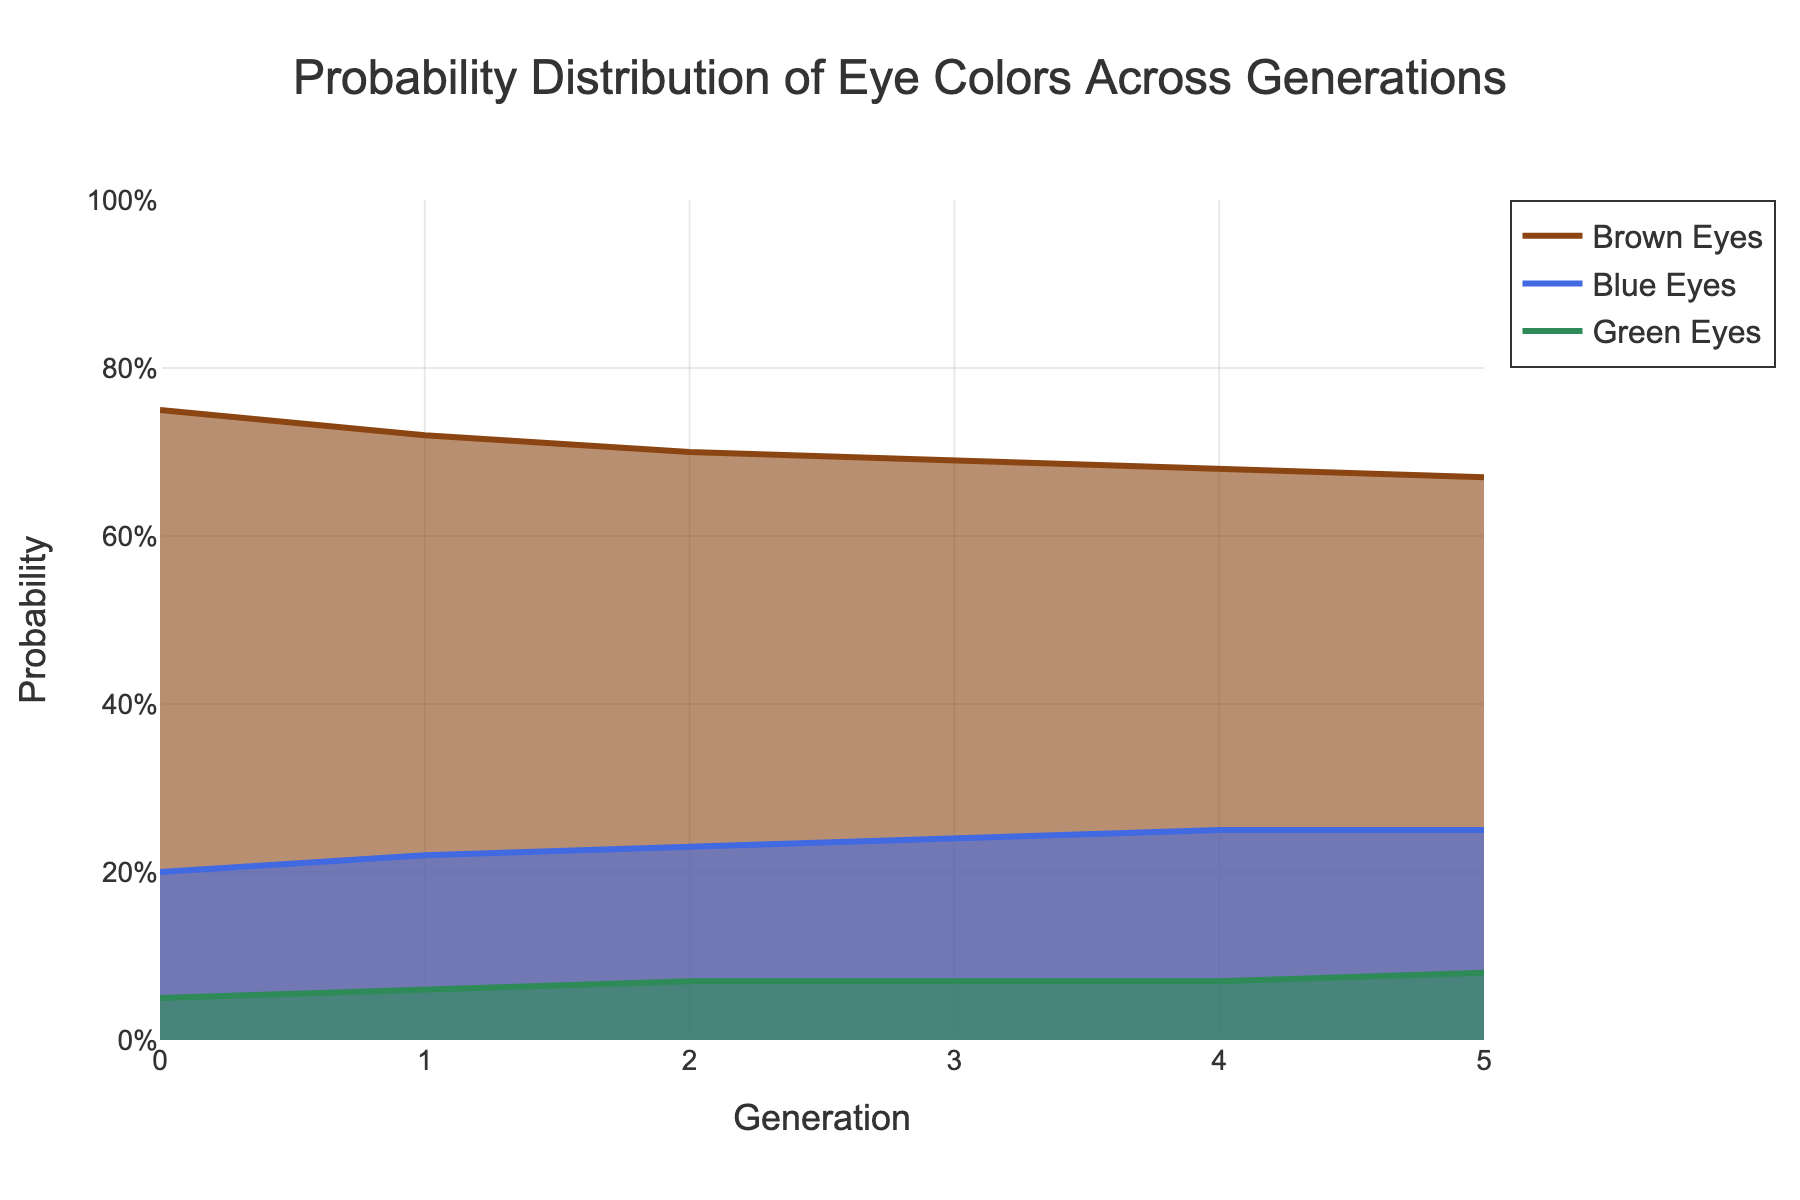What is the title of the figure? The title is displayed prominently at the top of the figure, indicating what the plot represents.
Answer: Probability Distribution of Eye Colors Across Generations What is the probability of having blue eyes in generation 2? Locate the line and area for blue eyes, and check the value on the y-axis where it intersects at generation 2 on the x-axis.
Answer: 0.23 How does the probability of having brown eyes change from generation 0 to generation 5? The probability of brown eyes starts at 0.75 in generation 0 and decreases slightly to 0.67 in generation 5.
Answer: It decreases by 0.08 Comparing the probabilities of blue eyes and green eyes in generation 4, which one is higher and by how much? Look at the y-axis values where the blue and green lines intersect with generation 4 on the x-axis. Blue eyes have a probability of 0.25 and green eyes have 0.07. The difference is 0.25 - 0.07.
Answer: Blue eyes, by 0.18 What trend do you observe for the probability of green eyes from generation 0 to generation 5? Observing the green area and line, the probability increases slightly over generations from 0.05 to 0.08.
Answer: It increases slightly What is the total probability for all the traits in generation 3? Sum up the probabilities of all traits in generation 3: 0.69 (Brown) + 0.24 (Blue) + 0.07 (Green).
Answer: 1.00 Which eye color has the most consistent probability over the generations? Compare the lines for each eye color. The line for Green eyes appears to be the most horizontal and consistent.
Answer: Green eyes How do the probabilities of blue and green eyes combined in generation 1 compare to the probability of brown eyes in the same generation? Add the probabilities of blue and green eyes in generation 1: 0.22 (Blue) + 0.06 (Green) = 0.28, then compare it to brown eyes (0.72).
Answer: Brown eyes are higher By how much does the probability of brown eyes decrease every generation on average? Calculate the difference from generation 0 to 5 (0.75 - 0.67 = 0.08), then divide by the number of generations (5), 0.08/5.
Answer: 0.016 per generation In which generation do blue eyes first surpass 0.24 in probability? Observe the blue line and find where it first reaches a probability higher than 0.24. This occurs between generation 3 and 4.
Answer: Generation 4 